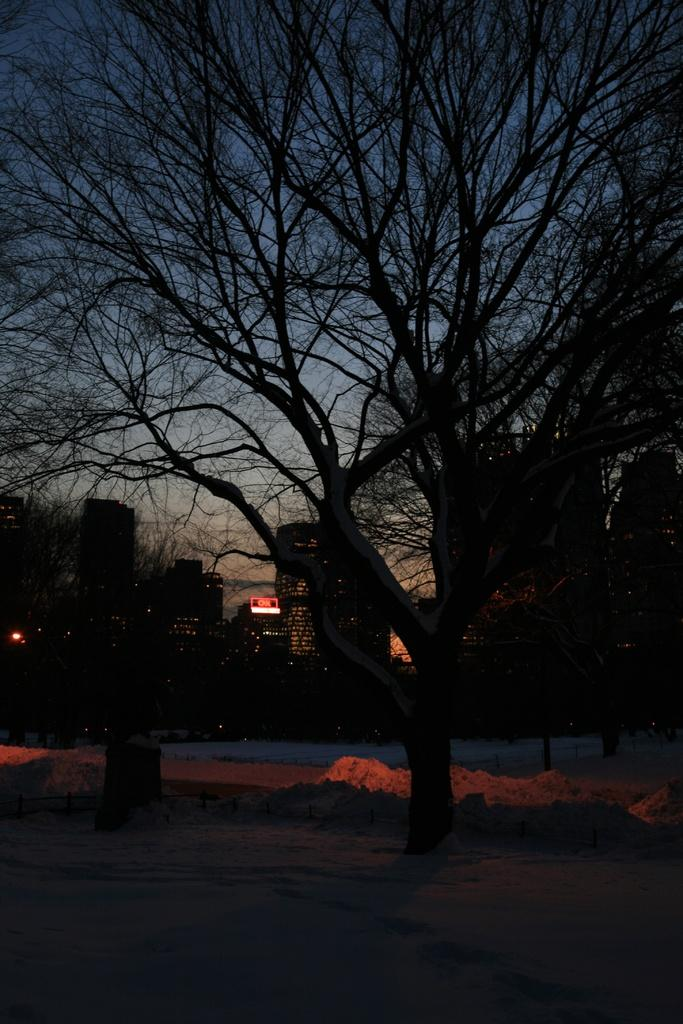What type of natural element is present in the image? There is a tree in the image. What part of the natural environment is visible in the image? The sky is visible in the image. What type of man-made structure is present in the image? There is a building in the image. What time of day was the image taken? The image was taken at night. How many bridges can be seen crossing the river in the image? There is no river or bridge present in the image. What type of act is being performed by the tree in the image? There is no act being performed by the tree in the image; it is a stationary natural element. 